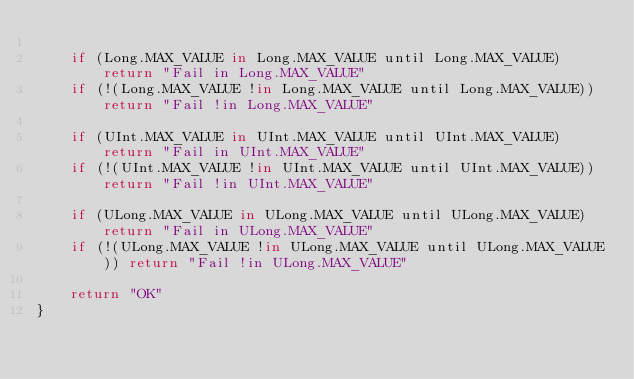<code> <loc_0><loc_0><loc_500><loc_500><_Kotlin_>
    if (Long.MAX_VALUE in Long.MAX_VALUE until Long.MAX_VALUE) return "Fail in Long.MAX_VALUE"
    if (!(Long.MAX_VALUE !in Long.MAX_VALUE until Long.MAX_VALUE)) return "Fail !in Long.MAX_VALUE"

    if (UInt.MAX_VALUE in UInt.MAX_VALUE until UInt.MAX_VALUE) return "Fail in UInt.MAX_VALUE"
    if (!(UInt.MAX_VALUE !in UInt.MAX_VALUE until UInt.MAX_VALUE)) return "Fail !in UInt.MAX_VALUE"

    if (ULong.MAX_VALUE in ULong.MAX_VALUE until ULong.MAX_VALUE) return "Fail in ULong.MAX_VALUE"
    if (!(ULong.MAX_VALUE !in ULong.MAX_VALUE until ULong.MAX_VALUE)) return "Fail !in ULong.MAX_VALUE"

    return "OK"
}</code> 